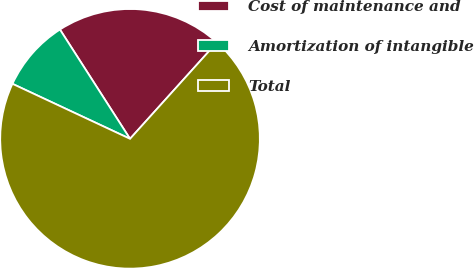Convert chart to OTSL. <chart><loc_0><loc_0><loc_500><loc_500><pie_chart><fcel>Cost of maintenance and<fcel>Amortization of intangible<fcel>Total<nl><fcel>20.75%<fcel>8.96%<fcel>70.28%<nl></chart> 